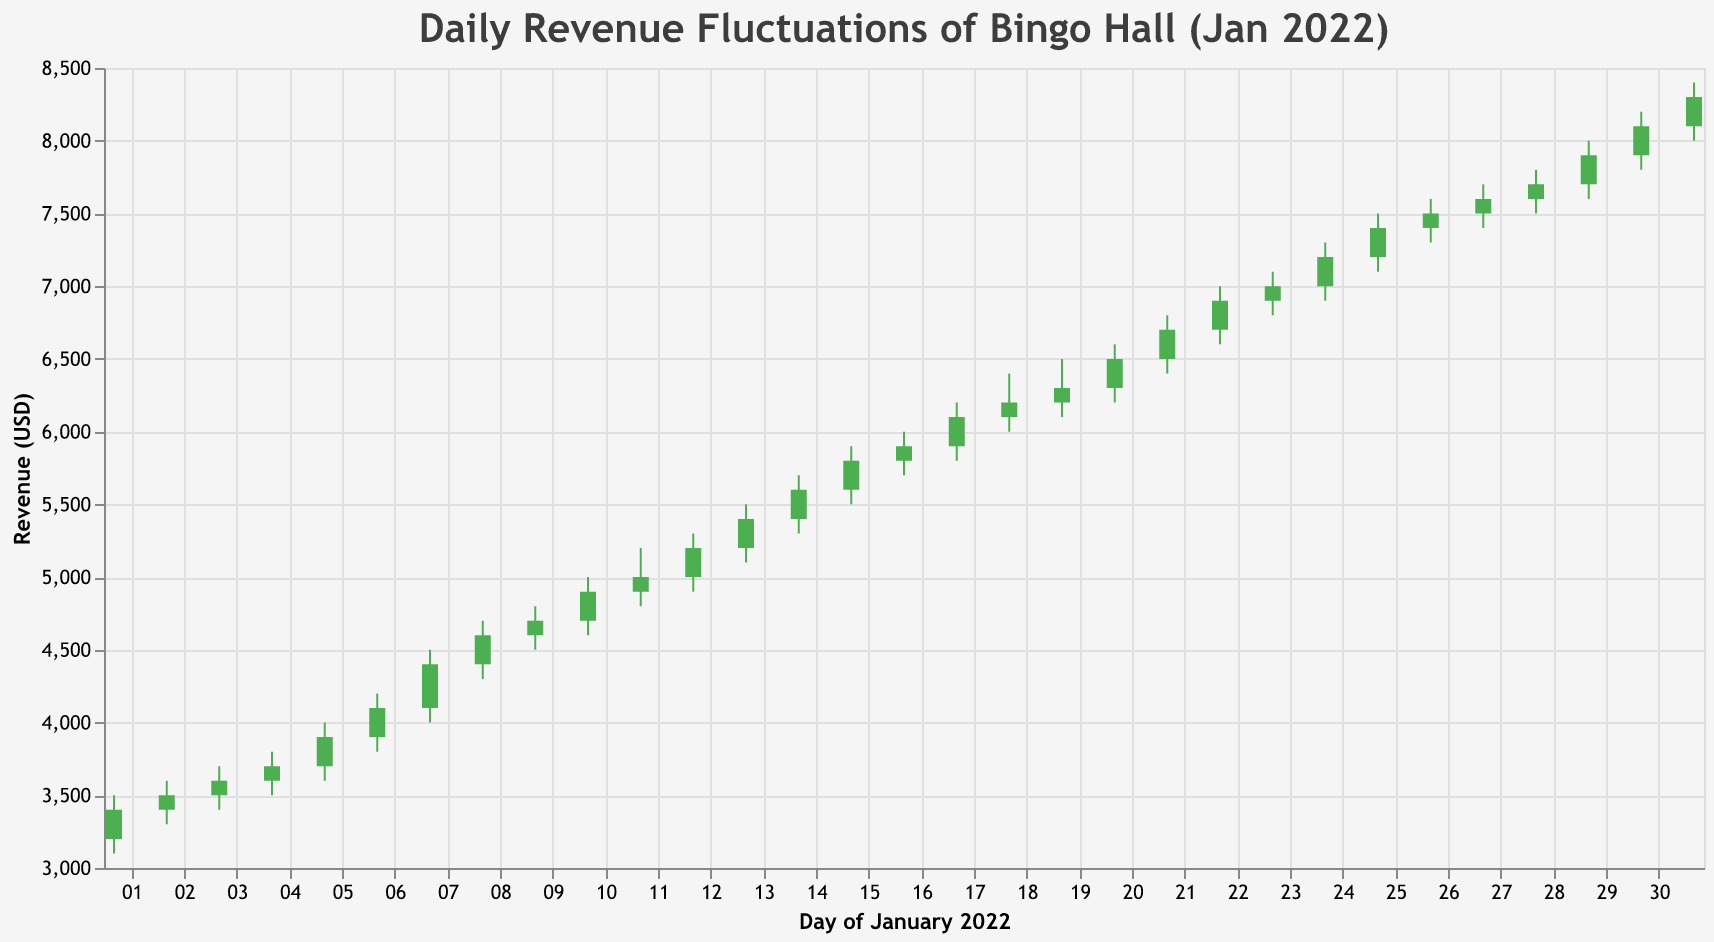What's the title of the figure? The title is displayed at the top of the figure, which is "Daily Revenue Fluctuations of Bingo Hall (Jan 2022)".
Answer: Daily Revenue Fluctuations of Bingo Hall (Jan 2022) What's the range of daily revenue for the entire month? The y-axis shows the scale of revenue, ranging from 3000 to 8500 USD.
Answer: 3000 to 8500 USD On which date did the revenue have the highest observed value? By referring to the highest points of the candlesticks, the highest revenue was observed on January 31, with a high of 8400 USD.
Answer: January 31 What was the revenue range (high and low) on January 15th? By looking at the candlestick for January 15th, the high is 5900 USD and the low is 5500 USD.
Answer: High: 5900, Low: 5500 Which date shows the largest fluctuation in revenue? The fluctuation can be measured by the difference between the high and low values. The largest fluctuation is on January 31st, with a high of 8400 and a low of 8000, making a fluctuation of 400 USD.
Answer: January 31 What's the average closing revenue for the first week of January? The first week includes dates from 1st to 7th. Closing values are 3400, 3500, 3600, 3700, 3900, 4100, and 4400. Sum is 26600, dividing by 7 gives an average of 3800 USD.
Answer: 3800 USD Comparing January 1st and January 31st, which day had a higher closing revenue? January 31st had a closing revenue of 8300 USD, while January 1st had 3400 USD, making January 31st the higher closing revenue day.
Answer: January 31 What was the price difference between the opening and closing values on January 20th? On January 20th, the open value was 6300 USD, and the close value was 6500 USD. The difference is 200 USD.
Answer: 200 USD Which day in January had the lowest closing revenue? Referring to the lowest points in the figure, January 1st had the lowest closing revenue at 3400 USD.
Answer: January 1 What is the median closing value of the revenues for the entire month? To find the median, list all closing values in ascending order and pick the middle value. For an even number of data points, average the two middle values. Closing values (sorted): 3400, 3500, 3600, 3700, 3900, 4100, 4400, 4600, 4700, 4900, 5000, 5200, 5400, 5600, 5800, 5900, 6100, 6200, 6300, 6500, 6700, 6900, 7000, 7200, 7400, 7500, 7600, 7700, 7900, 8100, 8300. The median is the 16th value, which is 5900 USD.
Answer: 5900 USD 